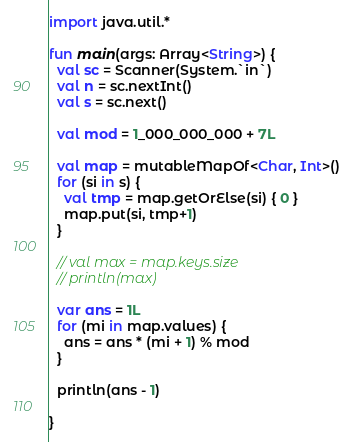Convert code to text. <code><loc_0><loc_0><loc_500><loc_500><_Kotlin_>import java.util.*

fun main(args: Array<String>) {
  val sc = Scanner(System.`in`)
  val n = sc.nextInt()
  val s = sc.next()

  val mod = 1_000_000_000 + 7L

  val map = mutableMapOf<Char, Int>()
  for (si in s) {
    val tmp = map.getOrElse(si) { 0 }
    map.put(si, tmp+1)
  }

  // val max = map.keys.size
  // println(max)

  var ans = 1L
  for (mi in map.values) {
    ans = ans * (mi + 1) % mod
  }

  println(ans - 1)

}
</code> 